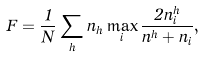Convert formula to latex. <formula><loc_0><loc_0><loc_500><loc_500>F = \frac { 1 } { N } \sum _ { h } n _ { h } \max _ { i } \frac { 2 n _ { i } ^ { h } } { n ^ { h } + n _ { i } } ,</formula> 